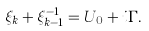<formula> <loc_0><loc_0><loc_500><loc_500>\xi _ { k } + \xi _ { k - 1 } ^ { - 1 } = U _ { 0 } + i \Gamma .</formula> 